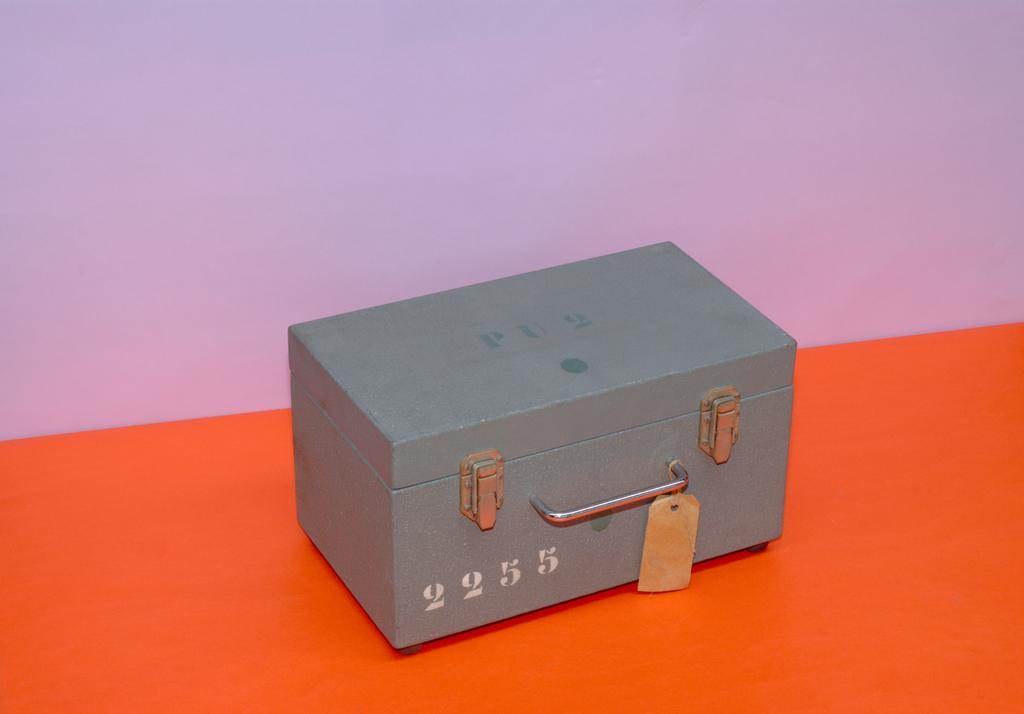<image>
Give a short and clear explanation of the subsequent image. A closed green container with the number 2255 on the side. 